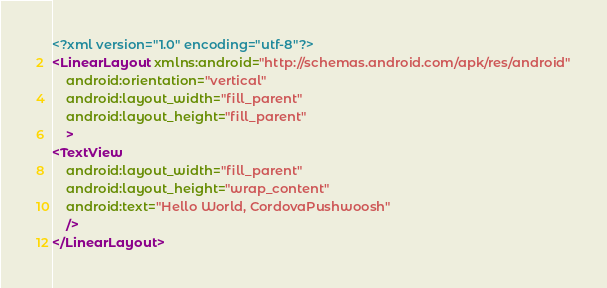<code> <loc_0><loc_0><loc_500><loc_500><_XML_><?xml version="1.0" encoding="utf-8"?>
<LinearLayout xmlns:android="http://schemas.android.com/apk/res/android"
    android:orientation="vertical"
    android:layout_width="fill_parent"
    android:layout_height="fill_parent"
    >
<TextView
    android:layout_width="fill_parent"
    android:layout_height="wrap_content"
    android:text="Hello World, CordovaPushwoosh"
    />
</LinearLayout>

</code> 